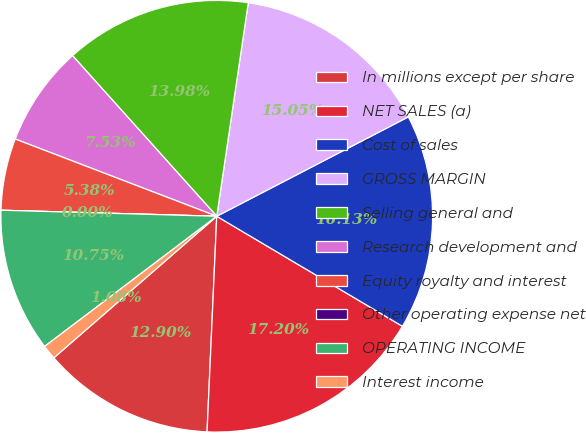Convert chart. <chart><loc_0><loc_0><loc_500><loc_500><pie_chart><fcel>In millions except per share<fcel>NET SALES (a)<fcel>Cost of sales<fcel>GROSS MARGIN<fcel>Selling general and<fcel>Research development and<fcel>Equity royalty and interest<fcel>Other operating expense net<fcel>OPERATING INCOME<fcel>Interest income<nl><fcel>12.9%<fcel>17.2%<fcel>16.13%<fcel>15.05%<fcel>13.98%<fcel>7.53%<fcel>5.38%<fcel>0.0%<fcel>10.75%<fcel>1.08%<nl></chart> 